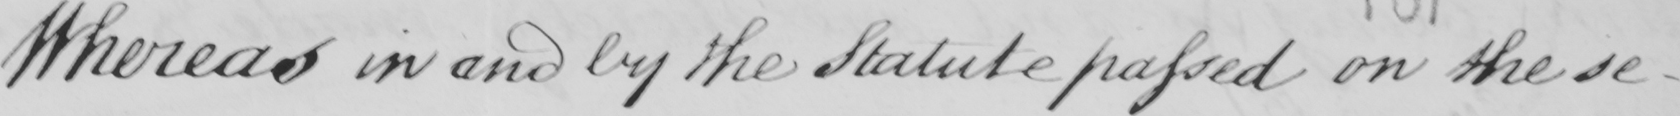What text is written in this handwritten line? Whereas in and by the Statute passed on the se- 